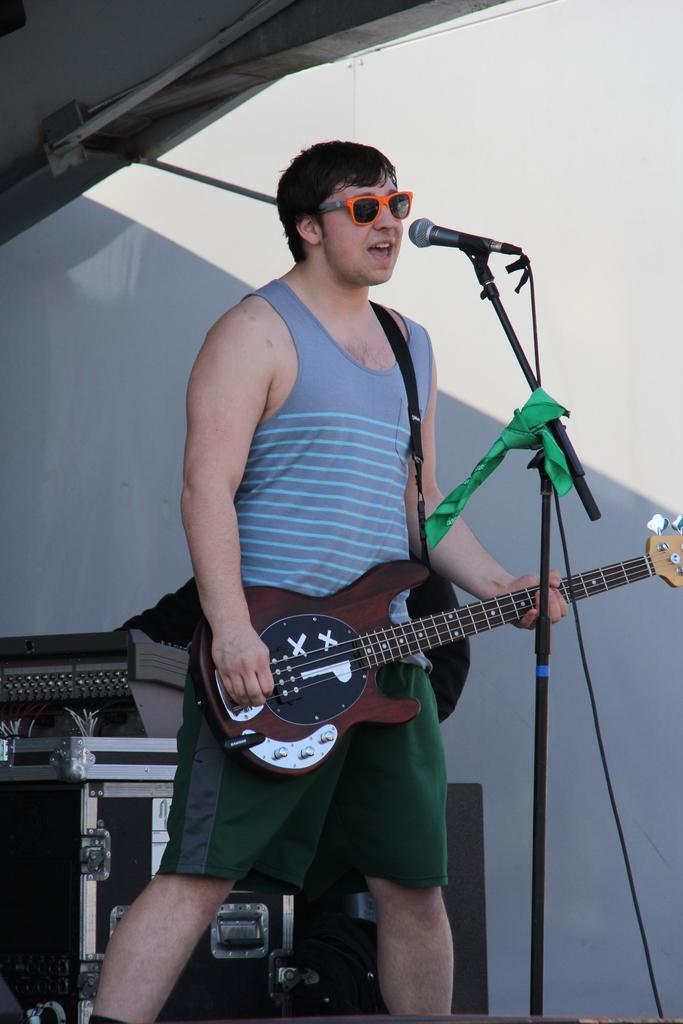What is the man in the image doing? The man is playing the guitar. What object is the man holding in the image? The man is holding a guitar. Where is the man positioned in relation to the microphone? The man is in front of a microphone. What can be seen in the background of the image? There are speakers and a wall in the background of the image. Can you tell me how many doctors are visible in the image? There are no doctors present in the image; it features a man playing a guitar. Is there a hill visible in the background of the image? There is no hill visible in the background of the image; it features speakers and a wall. 